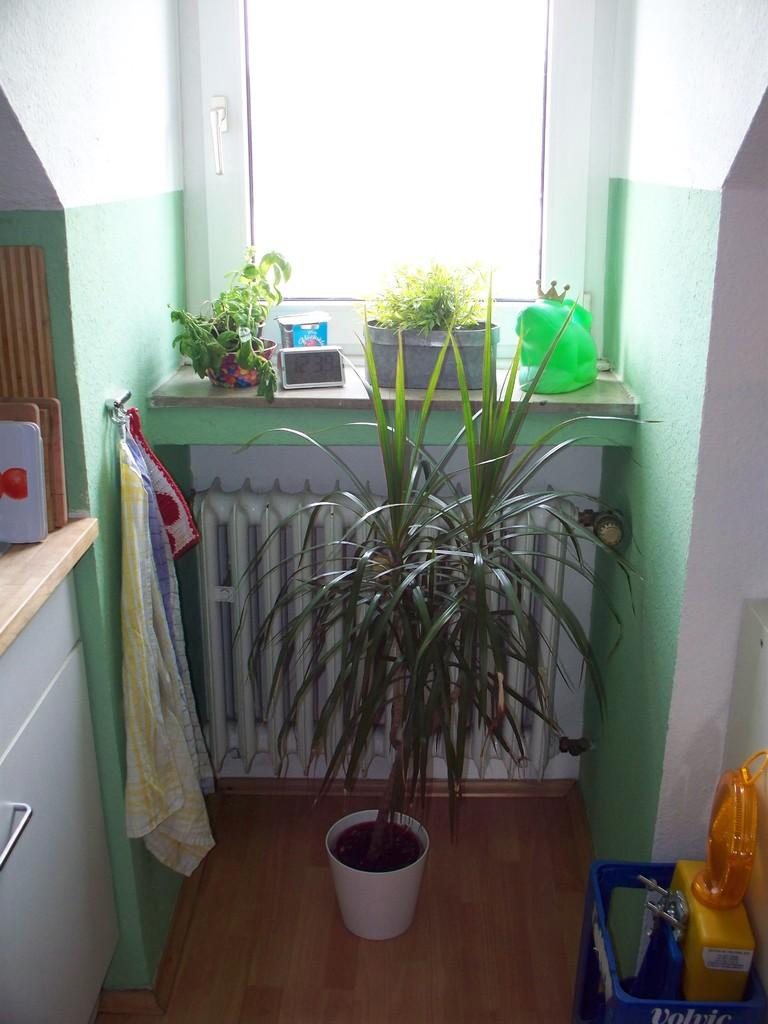What type of furniture is present in the image? There is a table in the image. What is placed on the table? There are flower pots on the table. What architectural feature can be seen in the image? There is a window in the image. What type of material is visible in the image? There is a cloth in the image. What type of living organism is present in the image? There is a plant in the image. What type of surface is visible in the image? There is a wall in the image. How many beds are visible in the image? There are no beds present in the image. What type of worm can be seen crawling on the plant in the image? There are no worms visible in the image, and the plant is not shown in a way that would allow us to see any insects or creatures on it. 